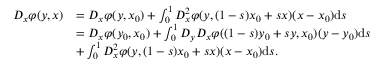Convert formula to latex. <formula><loc_0><loc_0><loc_500><loc_500>\begin{array} { r l } { D _ { x } \varphi ( y , x ) } & { = D _ { x } \varphi ( y , x _ { 0 } ) + \int _ { 0 } ^ { 1 } D _ { x } ^ { 2 } \varphi ( y , ( 1 - s ) x _ { 0 } + s x ) ( x - x _ { 0 } ) d s } \\ & { = D _ { x } \varphi ( y _ { 0 } , x _ { 0 } ) + \int _ { 0 } ^ { 1 } D _ { y } D _ { x } \varphi ( ( 1 - s ) y _ { 0 } + s y , x _ { 0 } ) ( y - y _ { 0 } ) d s } \\ & { + \int _ { 0 } ^ { 1 } D _ { x } ^ { 2 } \varphi ( y , ( 1 - s ) x _ { 0 } + s x ) ( x - x _ { 0 } ) d s . } \end{array}</formula> 